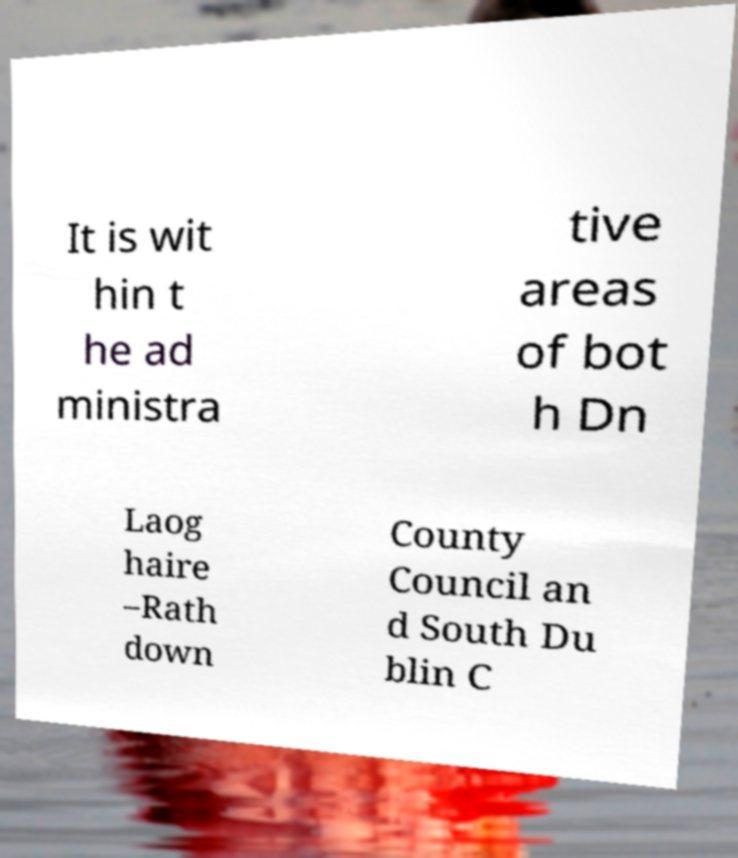I need the written content from this picture converted into text. Can you do that? It is wit hin t he ad ministra tive areas of bot h Dn Laog haire –Rath down County Council an d South Du blin C 